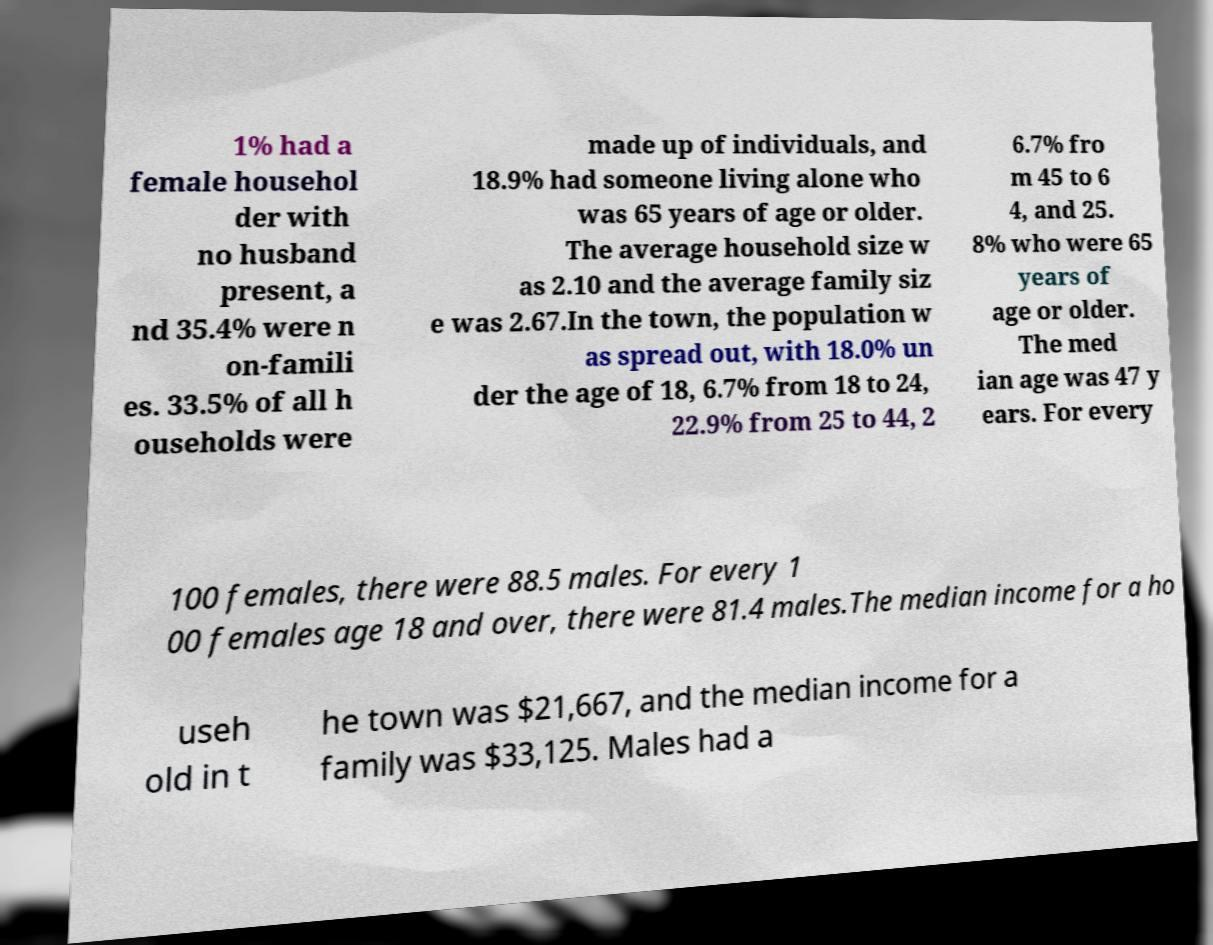Please identify and transcribe the text found in this image. 1% had a female househol der with no husband present, a nd 35.4% were n on-famili es. 33.5% of all h ouseholds were made up of individuals, and 18.9% had someone living alone who was 65 years of age or older. The average household size w as 2.10 and the average family siz e was 2.67.In the town, the population w as spread out, with 18.0% un der the age of 18, 6.7% from 18 to 24, 22.9% from 25 to 44, 2 6.7% fro m 45 to 6 4, and 25. 8% who were 65 years of age or older. The med ian age was 47 y ears. For every 100 females, there were 88.5 males. For every 1 00 females age 18 and over, there were 81.4 males.The median income for a ho useh old in t he town was $21,667, and the median income for a family was $33,125. Males had a 